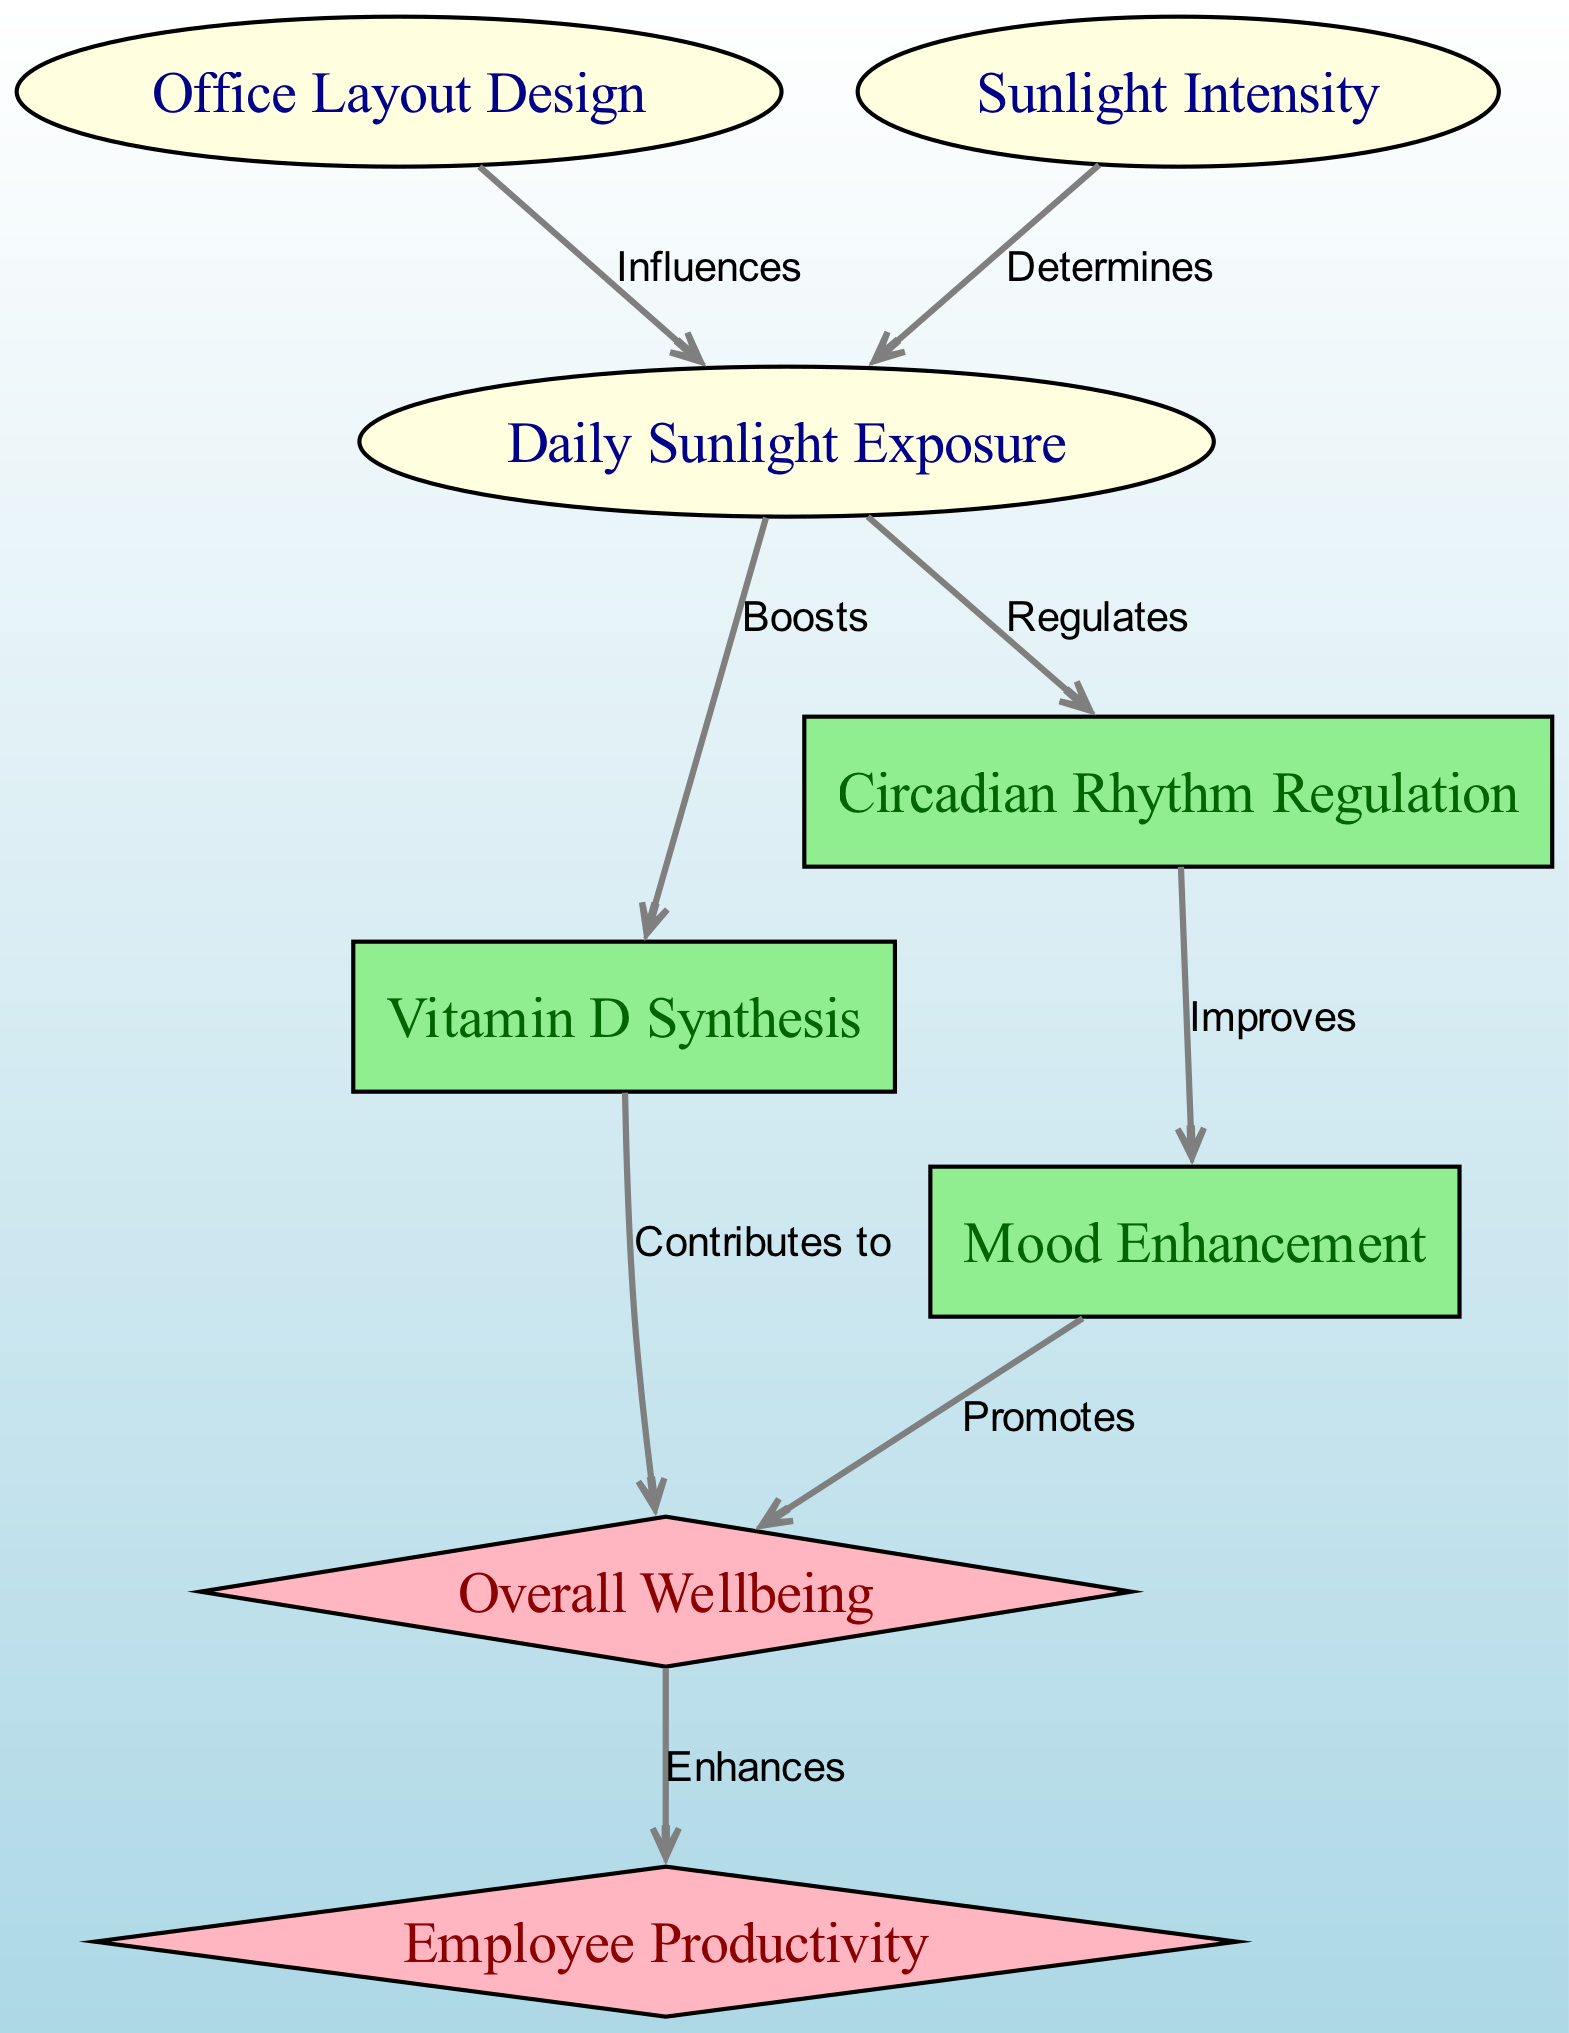What is the first node in the diagram? The first node in the diagram is "Daily Sunlight Exposure," which serves as an input. It is identified as the starting point for the processes that follow.
Answer: Daily Sunlight Exposure What type of node is "Circadian Rhythm Regulation"? "Circadian Rhythm Regulation" is classified as a process node in the diagram, indicated by its rectangular shape and light green color.
Answer: Process How many outcomes are present in the diagram? There are two outcome nodes in the diagram, which are "Overall Wellbeing" and "Employee Productivity." Each represents a result of the processes involved.
Answer: 2 What does "Vitamin D Synthesis" contribute to? "Vitamin D Synthesis" contributes to "Overall Wellbeing" according to the diagram, showing the effect of vitamin synthesis on a person's well-being.
Answer: Overall Wellbeing Which node influences "Daily Sunlight Exposure"? The node that influences "Daily Sunlight Exposure" is "Office Layout Design," demonstrating how the arrangement of an office can affect sunlight availability.
Answer: Office Layout Design What effect does "Circadian Rhythm Regulation" have on mood? "Circadian Rhythm Regulation" improves mood, indicating a direct positive impact on emotional state from healthy circadian rhythms.
Answer: Improves How is "Employee Productivity" enhanced? "Employee Productivity" is enhanced through the "Overall Wellbeing" node, which indicates that well-being leads to improved productivity in the workplace.
Answer: Overall Wellbeing What determines the "Daily Sunlight Exposure"? "Sunlight Intensity" determines "Daily Sunlight Exposure," highlighting the relationship between the intensity of sunlight and the amount of exposure received.
Answer: Sunlight Intensity What is the relationship between "Mood Enhancement" and "Overall Wellbeing"? The relationship shows that "Mood Enhancement" promotes "Overall Wellbeing," signifying that improved mood contributes positively to overall health and satisfaction.
Answer: Promotes 